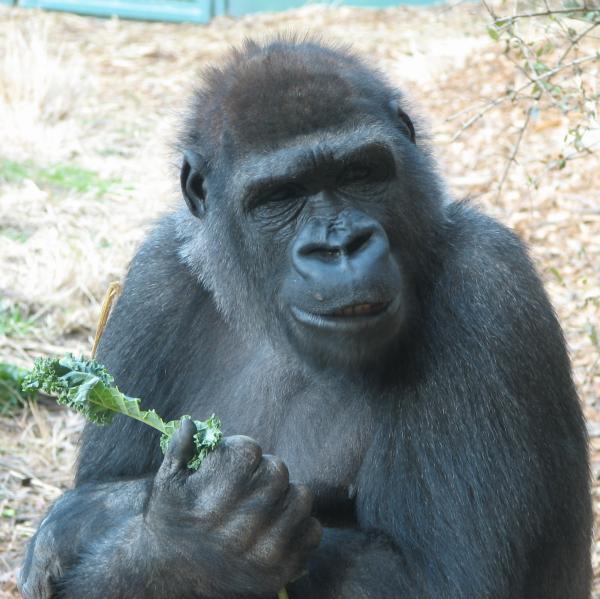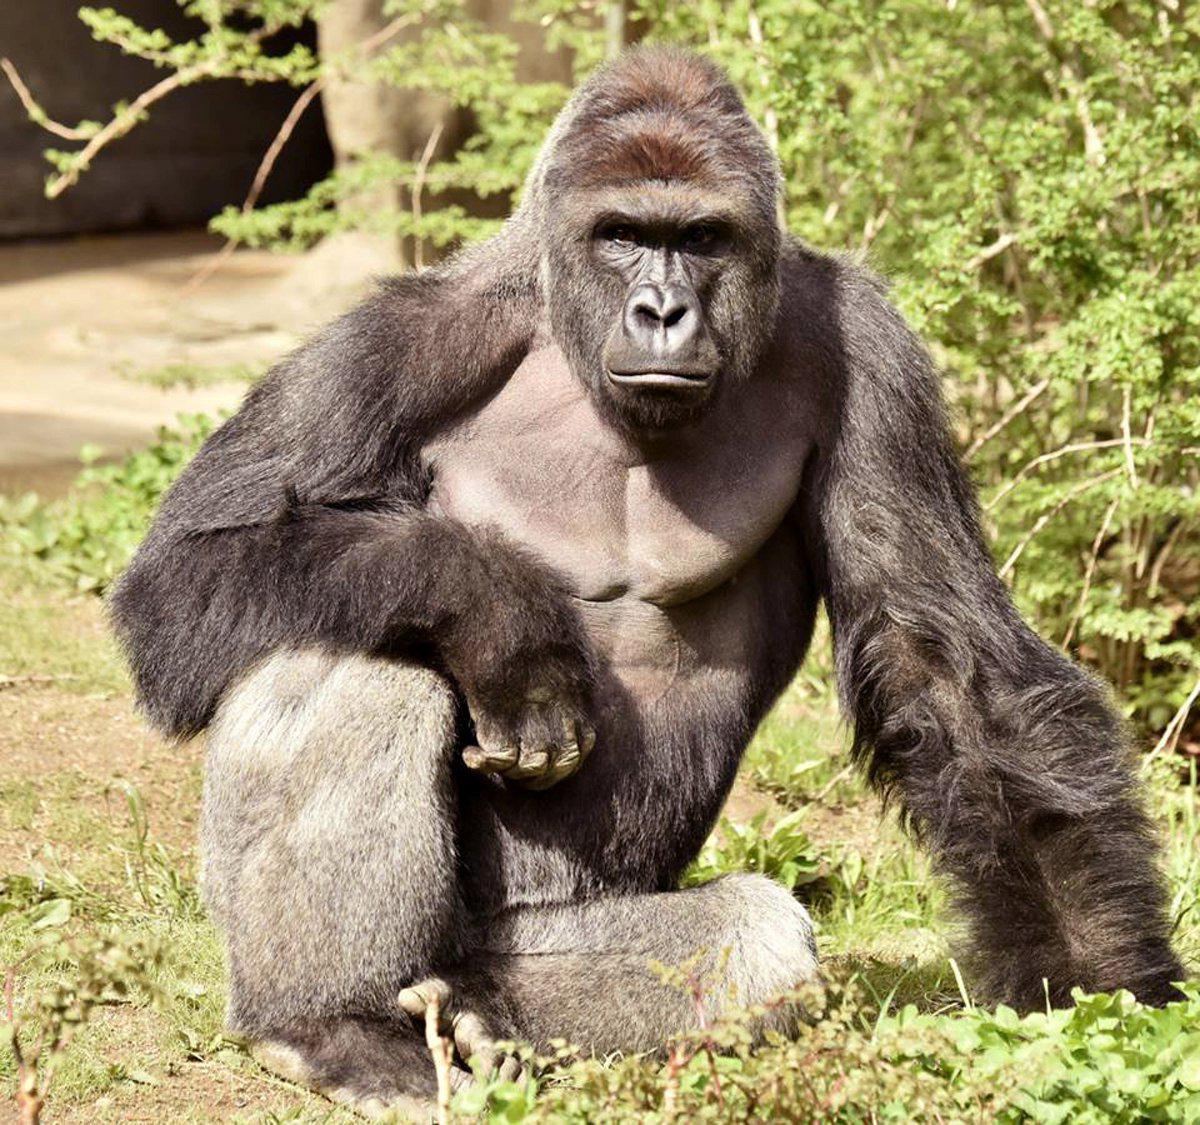The first image is the image on the left, the second image is the image on the right. Given the left and right images, does the statement "There is one sitting gorilla in the image on the right." hold true? Answer yes or no. Yes. 